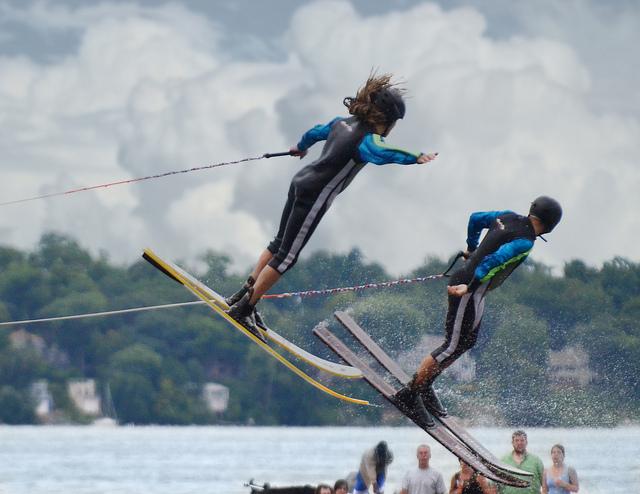Are they show skiers?
Be succinct. Yes. Are they well practiced?
Give a very brief answer. Yes. What is attached to the man's feet?
Keep it brief. Skis. Is this a kind of sport?
Be succinct. Yes. 